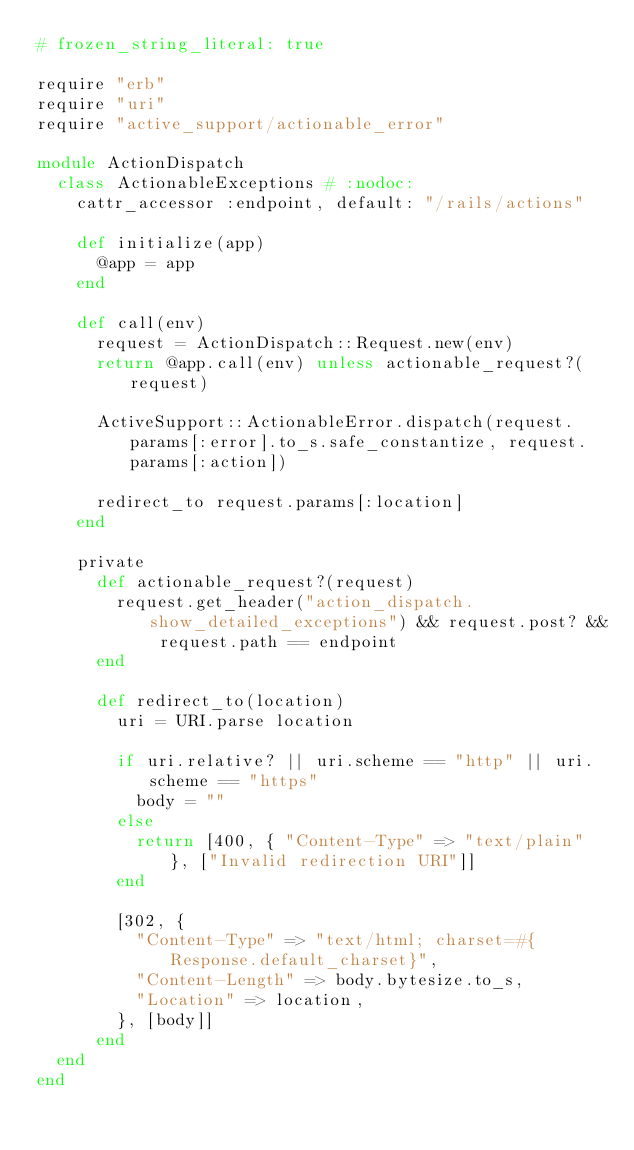Convert code to text. <code><loc_0><loc_0><loc_500><loc_500><_Ruby_># frozen_string_literal: true

require "erb"
require "uri"
require "active_support/actionable_error"

module ActionDispatch
  class ActionableExceptions # :nodoc:
    cattr_accessor :endpoint, default: "/rails/actions"

    def initialize(app)
      @app = app
    end

    def call(env)
      request = ActionDispatch::Request.new(env)
      return @app.call(env) unless actionable_request?(request)

      ActiveSupport::ActionableError.dispatch(request.params[:error].to_s.safe_constantize, request.params[:action])

      redirect_to request.params[:location]
    end

    private
      def actionable_request?(request)
        request.get_header("action_dispatch.show_detailed_exceptions") && request.post? && request.path == endpoint
      end

      def redirect_to(location)
        uri = URI.parse location

        if uri.relative? || uri.scheme == "http" || uri.scheme == "https"
          body = ""
        else
          return [400, { "Content-Type" => "text/plain" }, ["Invalid redirection URI"]]
        end

        [302, {
          "Content-Type" => "text/html; charset=#{Response.default_charset}",
          "Content-Length" => body.bytesize.to_s,
          "Location" => location,
        }, [body]]
      end
  end
end
</code> 